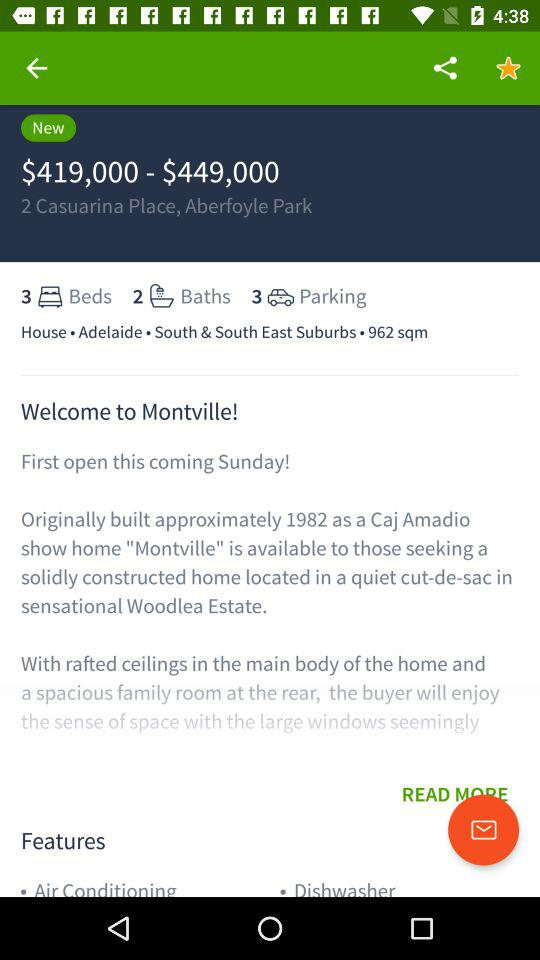What is the available count of bathrooms? The available count of bathrooms is 2. 